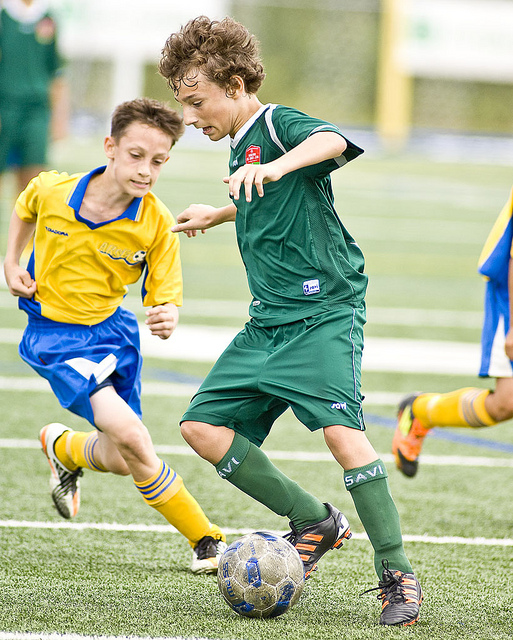Identify the text displayed in this image. SAVI AVI mess 